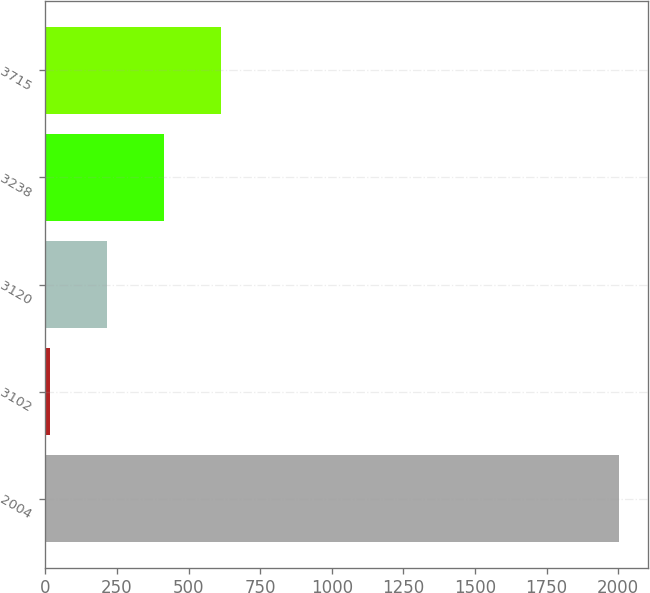Convert chart to OTSL. <chart><loc_0><loc_0><loc_500><loc_500><bar_chart><fcel>2004<fcel>3102<fcel>3120<fcel>3238<fcel>3715<nl><fcel>2003<fcel>15.71<fcel>214.44<fcel>413.17<fcel>611.9<nl></chart> 